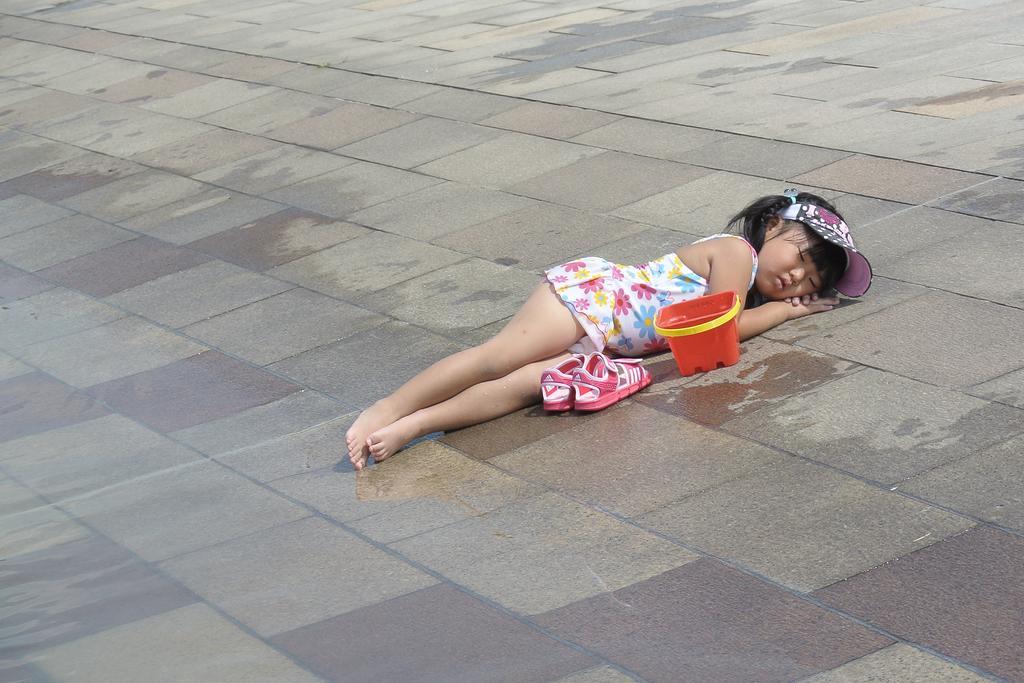Describe this image in one or two sentences. In this image we can see a kid wearing multi color dress sleeping on ground, there is a pair of shoes and a box beside her. 